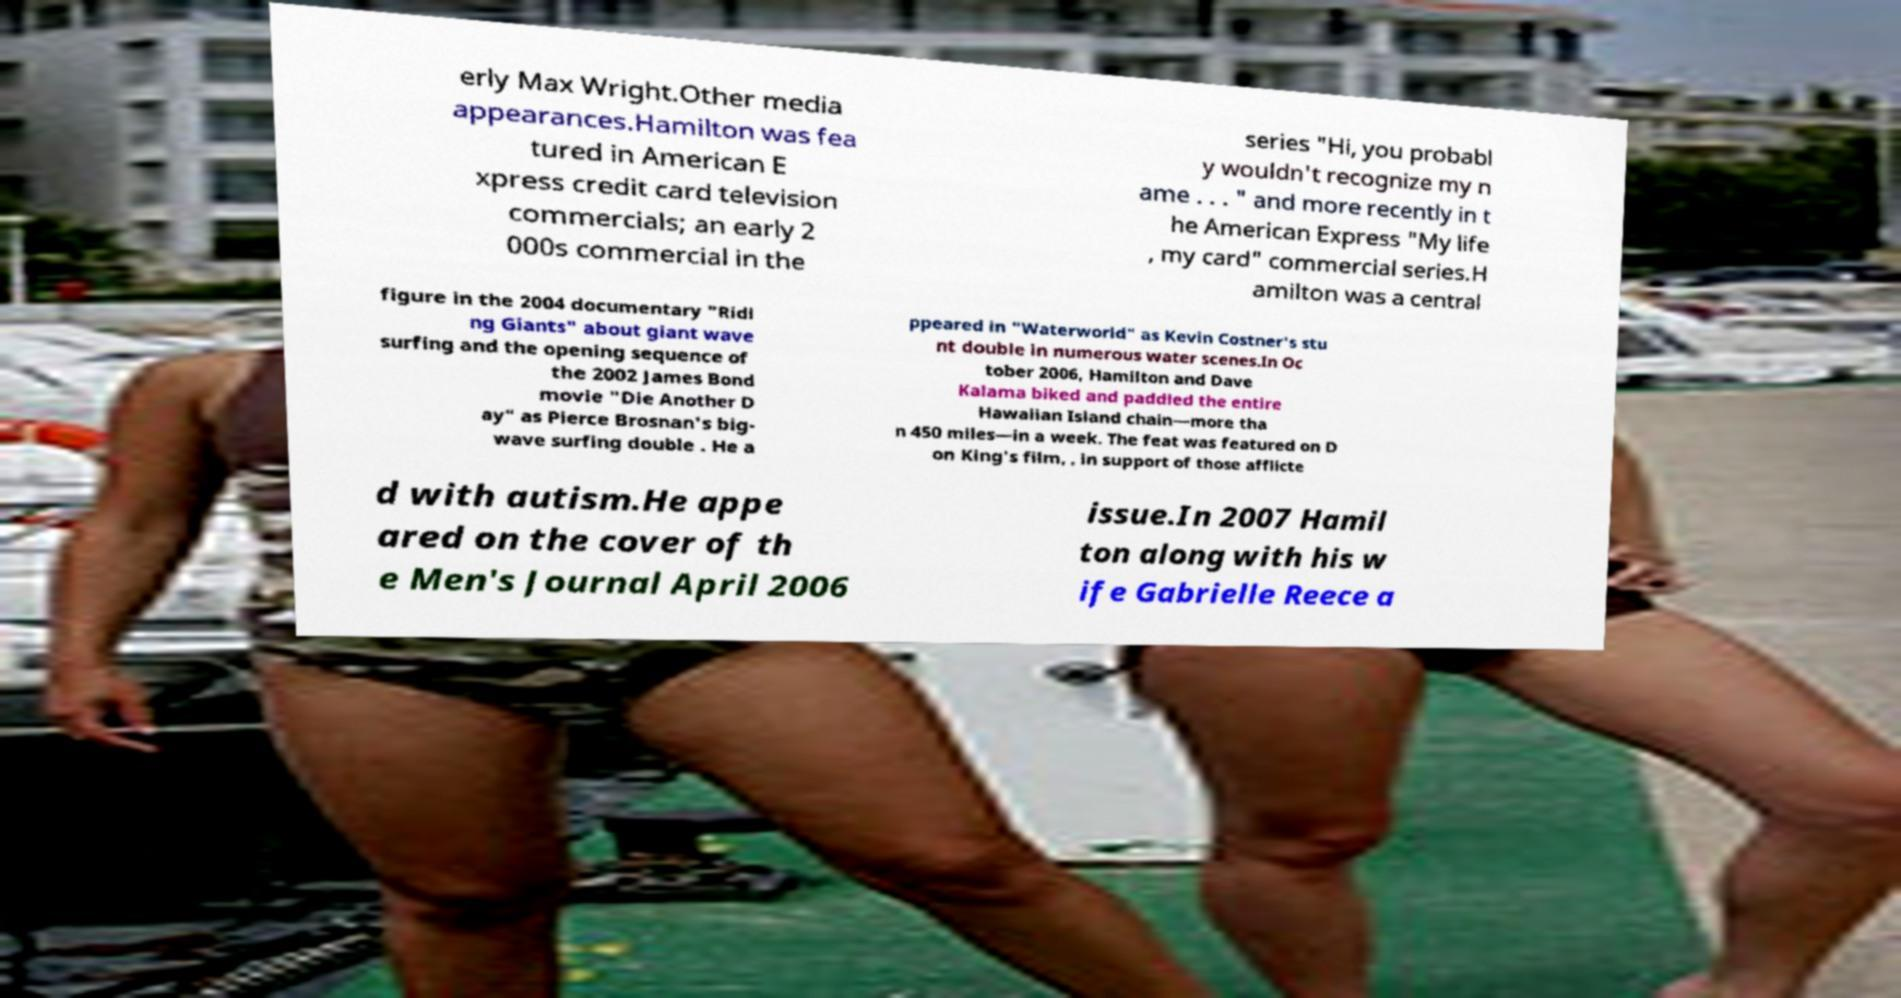There's text embedded in this image that I need extracted. Can you transcribe it verbatim? erly Max Wright.Other media appearances.Hamilton was fea tured in American E xpress credit card television commercials; an early 2 000s commercial in the series "Hi, you probabl y wouldn't recognize my n ame . . . " and more recently in t he American Express "My life , my card" commercial series.H amilton was a central figure in the 2004 documentary "Ridi ng Giants" about giant wave surfing and the opening sequence of the 2002 James Bond movie "Die Another D ay" as Pierce Brosnan's big- wave surfing double . He a ppeared in "Waterworld" as Kevin Costner's stu nt double in numerous water scenes.In Oc tober 2006, Hamilton and Dave Kalama biked and paddled the entire Hawaiian Island chain—more tha n 450 miles—in a week. The feat was featured on D on King's film, , in support of those afflicte d with autism.He appe ared on the cover of th e Men's Journal April 2006 issue.In 2007 Hamil ton along with his w ife Gabrielle Reece a 